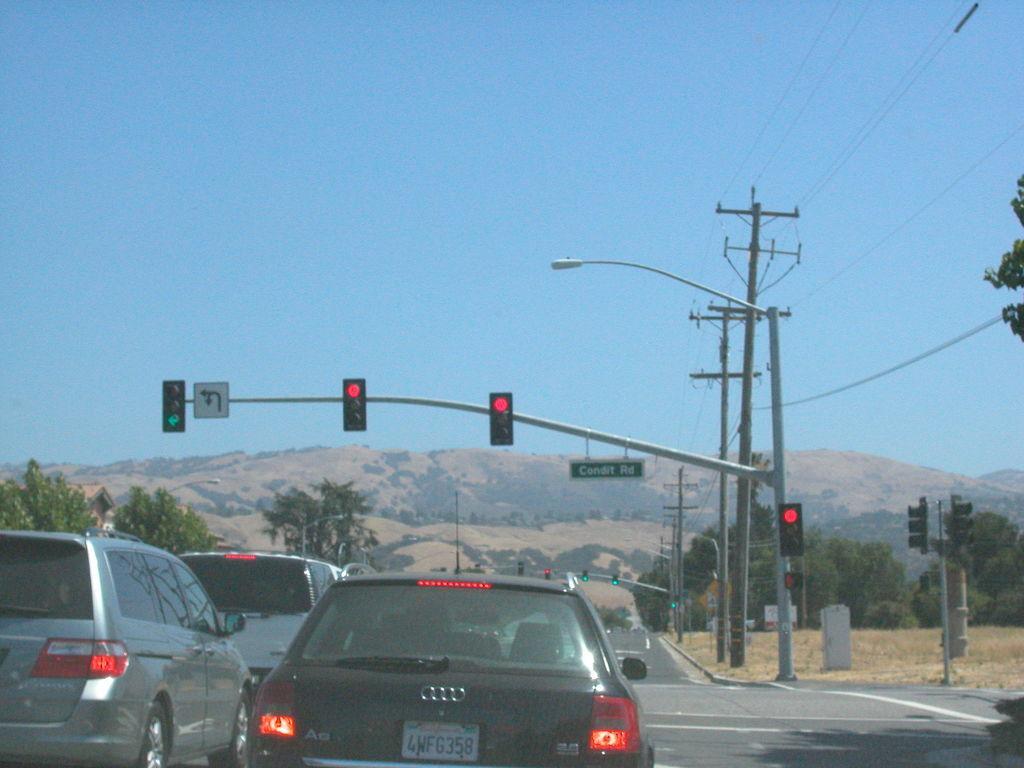Describe this image in one or two sentences. In this picture there are few vehicles on the road and there are traffic signals in front of it and there are trees on either sides of it and there are few poles in the right corner and there are mountains in the background. 